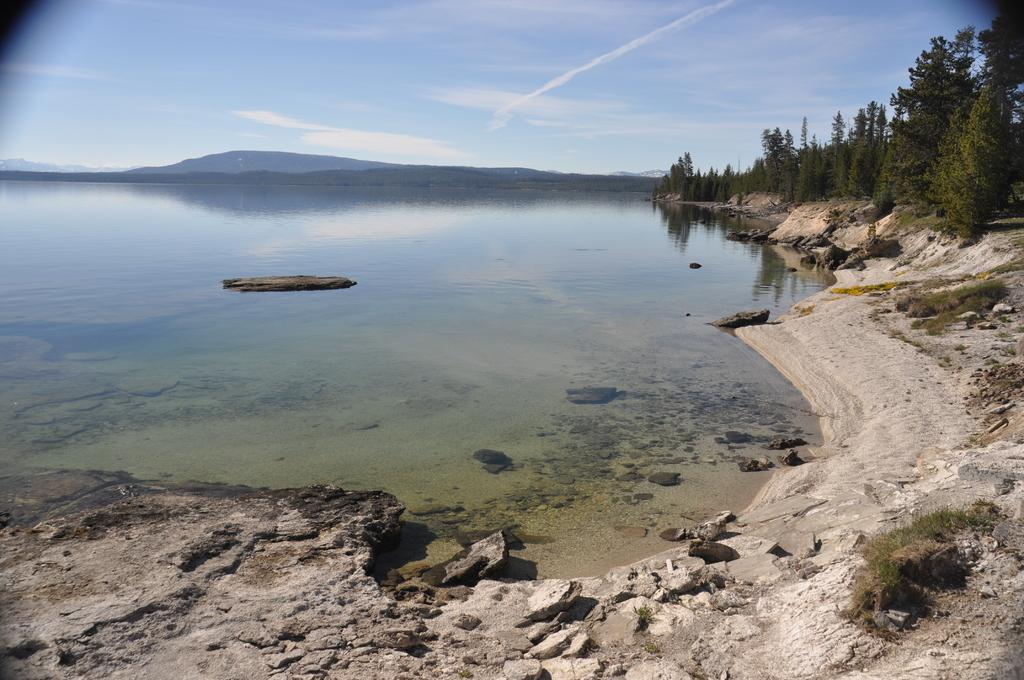What is the main element in the center of the image? There is water in the center of the image. What type of vegetation or plants can be seen in the image? There is greenery in the image. How would you describe the condition of the floor at the bottom side of the image? The floor at the bottom side of the image appears to be muddy. Where is the crayon located in the image? There is no crayon present in the image. 